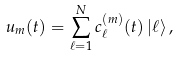<formula> <loc_0><loc_0><loc_500><loc_500>u _ { m } ( t ) = \sum _ { \ell = 1 } ^ { N } c _ { \ell } ^ { ( m ) } ( t ) \, | \ell \rangle \, ,</formula> 